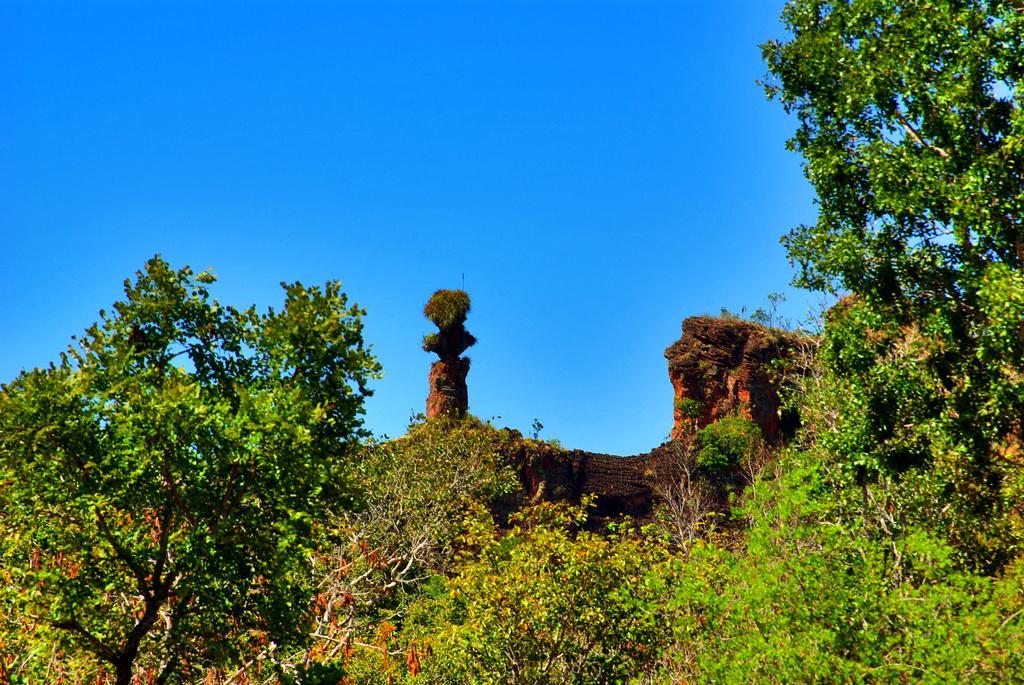Can you describe this image briefly? This image consists of trees. In the front, we can see a wall like structure. At the top, there is sky. 